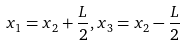<formula> <loc_0><loc_0><loc_500><loc_500>x _ { 1 } = x _ { 2 } + \frac { L } { 2 } , x _ { 3 } = x _ { 2 } - \frac { L } { 2 }</formula> 